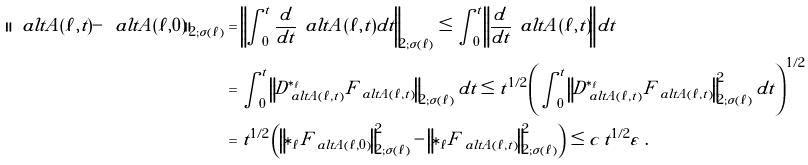<formula> <loc_0><loc_0><loc_500><loc_500>\| \ a l t A ( \ell , t ) - \ a l t A ( \ell , 0 ) \| _ { 2 ; \sigma ( \ell ) } & = \left \| \int _ { 0 } ^ { t } \frac { d } { d t } \, \ a l t A ( \ell , t ) d t \right \| _ { 2 ; \sigma ( \ell ) } \leq \int _ { 0 } ^ { t } \left \| \frac { d } { d t } \, \ a l t A ( \ell , t ) \right \| d t \\ & = \int _ { 0 } ^ { t } \left \| D ^ { \ast _ { \ell } } _ { \ a l t A ( \ell , t ) } F _ { \ a l t A ( \ell , t ) } \right \| _ { 2 ; \sigma ( \ell ) } d t \leq t ^ { 1 / 2 } \left ( \int _ { 0 } ^ { t } \left \| D ^ { \ast _ { \ell } } _ { \ a l t A ( \ell , t ) } F _ { \ a l t A ( \ell , t ) } \right \| ^ { 2 } _ { 2 ; \sigma ( \ell ) } d t \right ) ^ { 1 / 2 } \\ & = t ^ { 1 / 2 } \left ( \left \| \ast _ { \ell } F _ { \ a l t A ( \ell , 0 ) } \right \| ^ { 2 } _ { 2 ; \sigma ( \ell ) } - \left \| \ast _ { \ell } F _ { \ a l t A ( \ell , t ) } \right \| ^ { 2 } _ { 2 ; \sigma ( \ell ) } \right ) \leq c \, t ^ { 1 / 2 } \varepsilon \ .</formula> 